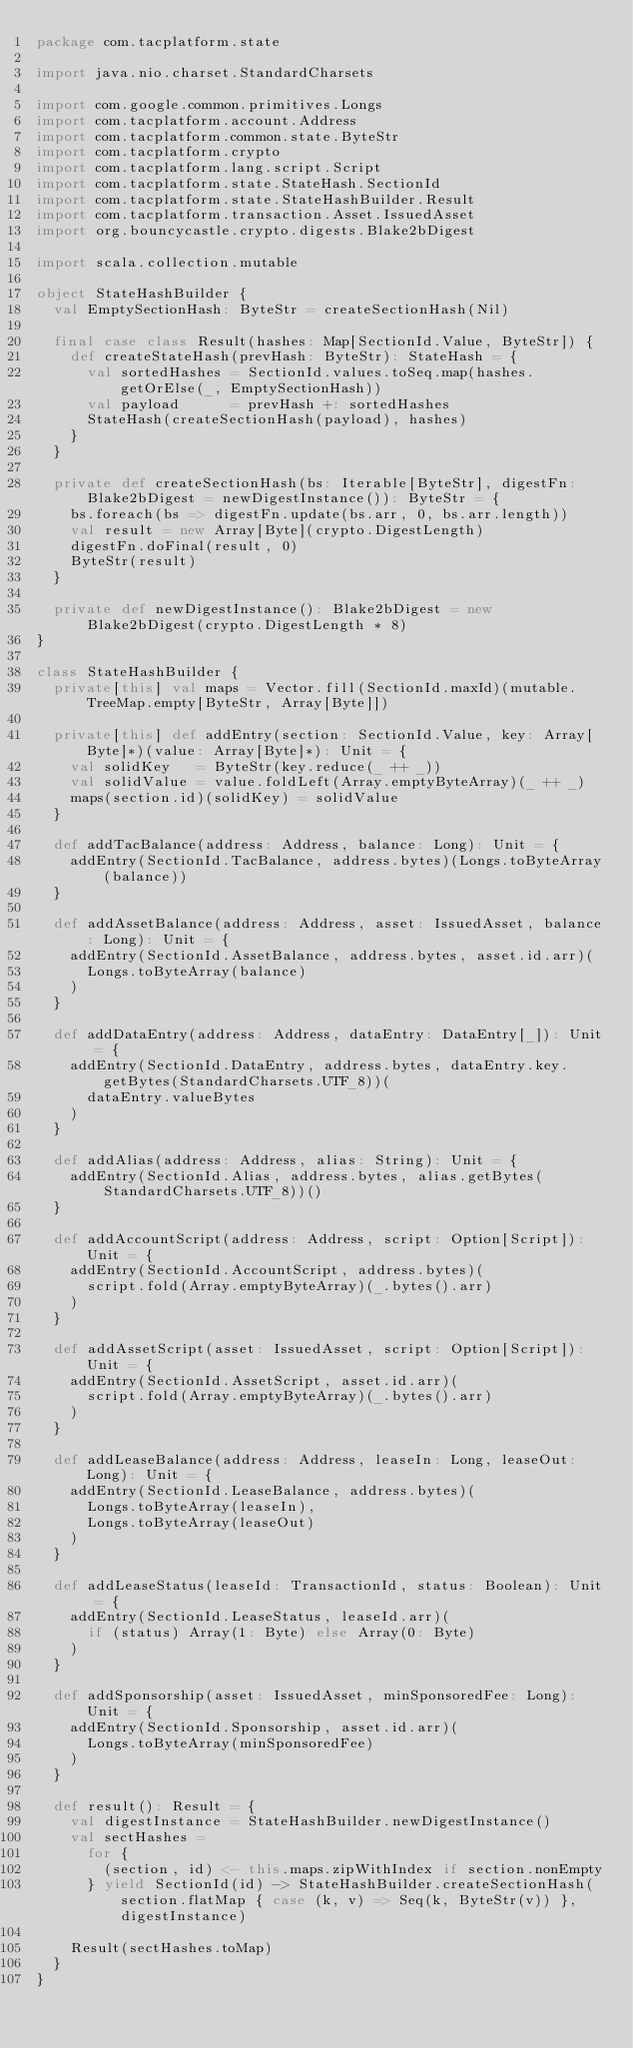Convert code to text. <code><loc_0><loc_0><loc_500><loc_500><_Scala_>package com.tacplatform.state

import java.nio.charset.StandardCharsets

import com.google.common.primitives.Longs
import com.tacplatform.account.Address
import com.tacplatform.common.state.ByteStr
import com.tacplatform.crypto
import com.tacplatform.lang.script.Script
import com.tacplatform.state.StateHash.SectionId
import com.tacplatform.state.StateHashBuilder.Result
import com.tacplatform.transaction.Asset.IssuedAsset
import org.bouncycastle.crypto.digests.Blake2bDigest

import scala.collection.mutable

object StateHashBuilder {
  val EmptySectionHash: ByteStr = createSectionHash(Nil)

  final case class Result(hashes: Map[SectionId.Value, ByteStr]) {
    def createStateHash(prevHash: ByteStr): StateHash = {
      val sortedHashes = SectionId.values.toSeq.map(hashes.getOrElse(_, EmptySectionHash))
      val payload      = prevHash +: sortedHashes
      StateHash(createSectionHash(payload), hashes)
    }
  }

  private def createSectionHash(bs: Iterable[ByteStr], digestFn: Blake2bDigest = newDigestInstance()): ByteStr = {
    bs.foreach(bs => digestFn.update(bs.arr, 0, bs.arr.length))
    val result = new Array[Byte](crypto.DigestLength)
    digestFn.doFinal(result, 0)
    ByteStr(result)
  }

  private def newDigestInstance(): Blake2bDigest = new Blake2bDigest(crypto.DigestLength * 8)
}

class StateHashBuilder {
  private[this] val maps = Vector.fill(SectionId.maxId)(mutable.TreeMap.empty[ByteStr, Array[Byte]])

  private[this] def addEntry(section: SectionId.Value, key: Array[Byte]*)(value: Array[Byte]*): Unit = {
    val solidKey   = ByteStr(key.reduce(_ ++ _))
    val solidValue = value.foldLeft(Array.emptyByteArray)(_ ++ _)
    maps(section.id)(solidKey) = solidValue
  }

  def addTacBalance(address: Address, balance: Long): Unit = {
    addEntry(SectionId.TacBalance, address.bytes)(Longs.toByteArray(balance))
  }

  def addAssetBalance(address: Address, asset: IssuedAsset, balance: Long): Unit = {
    addEntry(SectionId.AssetBalance, address.bytes, asset.id.arr)(
      Longs.toByteArray(balance)
    )
  }

  def addDataEntry(address: Address, dataEntry: DataEntry[_]): Unit = {
    addEntry(SectionId.DataEntry, address.bytes, dataEntry.key.getBytes(StandardCharsets.UTF_8))(
      dataEntry.valueBytes
    )
  }

  def addAlias(address: Address, alias: String): Unit = {
    addEntry(SectionId.Alias, address.bytes, alias.getBytes(StandardCharsets.UTF_8))()
  }

  def addAccountScript(address: Address, script: Option[Script]): Unit = {
    addEntry(SectionId.AccountScript, address.bytes)(
      script.fold(Array.emptyByteArray)(_.bytes().arr)
    )
  }

  def addAssetScript(asset: IssuedAsset, script: Option[Script]): Unit = {
    addEntry(SectionId.AssetScript, asset.id.arr)(
      script.fold(Array.emptyByteArray)(_.bytes().arr)
    )
  }

  def addLeaseBalance(address: Address, leaseIn: Long, leaseOut: Long): Unit = {
    addEntry(SectionId.LeaseBalance, address.bytes)(
      Longs.toByteArray(leaseIn),
      Longs.toByteArray(leaseOut)
    )
  }

  def addLeaseStatus(leaseId: TransactionId, status: Boolean): Unit = {
    addEntry(SectionId.LeaseStatus, leaseId.arr)(
      if (status) Array(1: Byte) else Array(0: Byte)
    )
  }

  def addSponsorship(asset: IssuedAsset, minSponsoredFee: Long): Unit = {
    addEntry(SectionId.Sponsorship, asset.id.arr)(
      Longs.toByteArray(minSponsoredFee)
    )
  }

  def result(): Result = {
    val digestInstance = StateHashBuilder.newDigestInstance()
    val sectHashes =
      for {
        (section, id) <- this.maps.zipWithIndex if section.nonEmpty
      } yield SectionId(id) -> StateHashBuilder.createSectionHash(section.flatMap { case (k, v) => Seq(k, ByteStr(v)) }, digestInstance)

    Result(sectHashes.toMap)
  }
}
</code> 